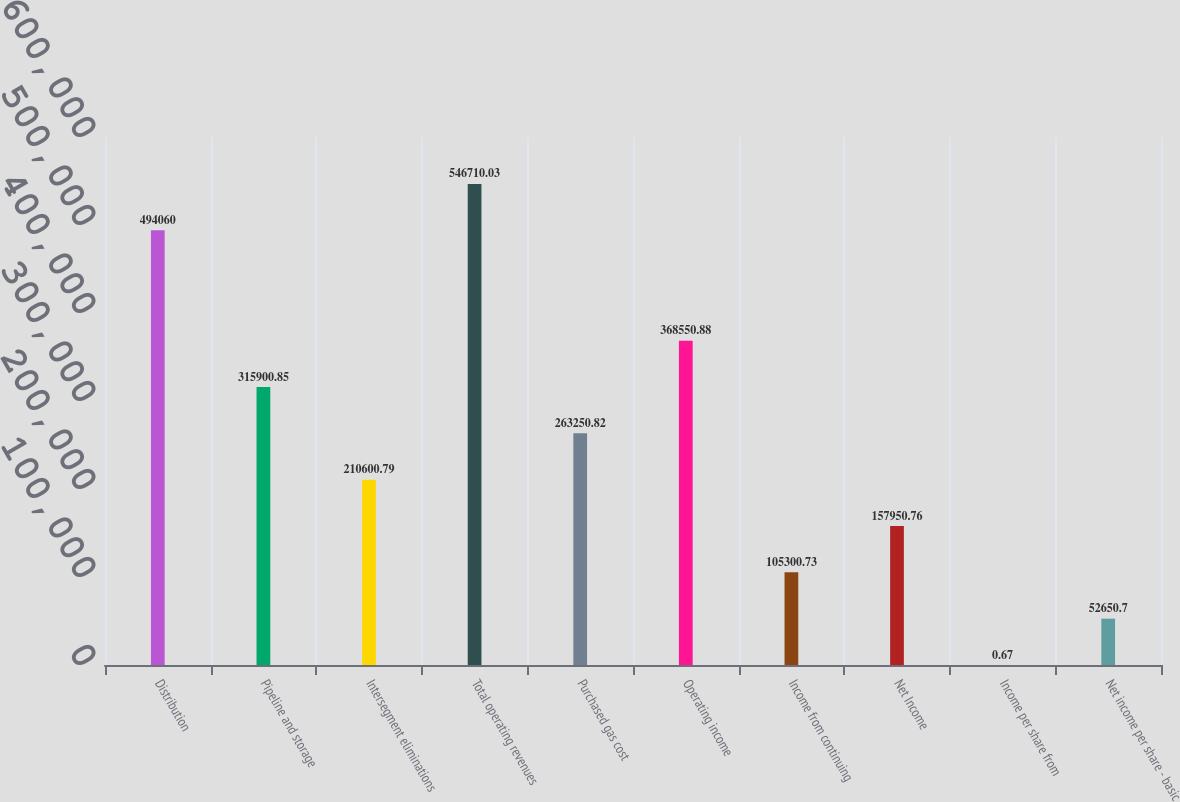Convert chart. <chart><loc_0><loc_0><loc_500><loc_500><bar_chart><fcel>Distribution<fcel>Pipeline and storage<fcel>Intersegment eliminations<fcel>Total operating revenues<fcel>Purchased gas cost<fcel>Operating income<fcel>Income from continuing<fcel>Net Income<fcel>Income per share from<fcel>Net income per share - basic<nl><fcel>494060<fcel>315901<fcel>210601<fcel>546710<fcel>263251<fcel>368551<fcel>105301<fcel>157951<fcel>0.67<fcel>52650.7<nl></chart> 